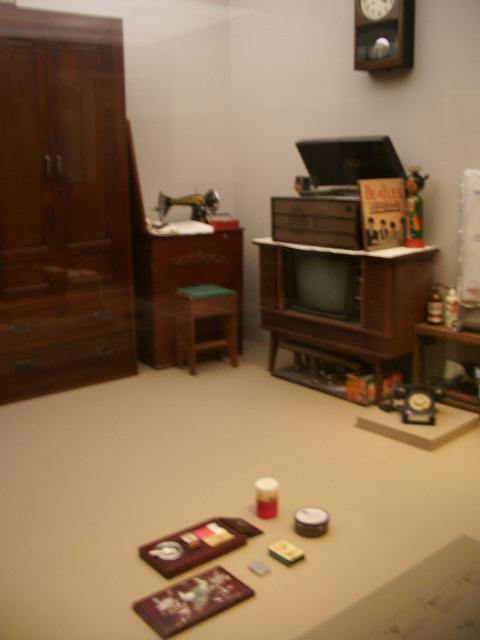What is able to be repaired by the machine in the corner?
From the following four choices, select the correct answer to address the question.
Options: Tv, ovens, clothing, shoes. Clothing. 